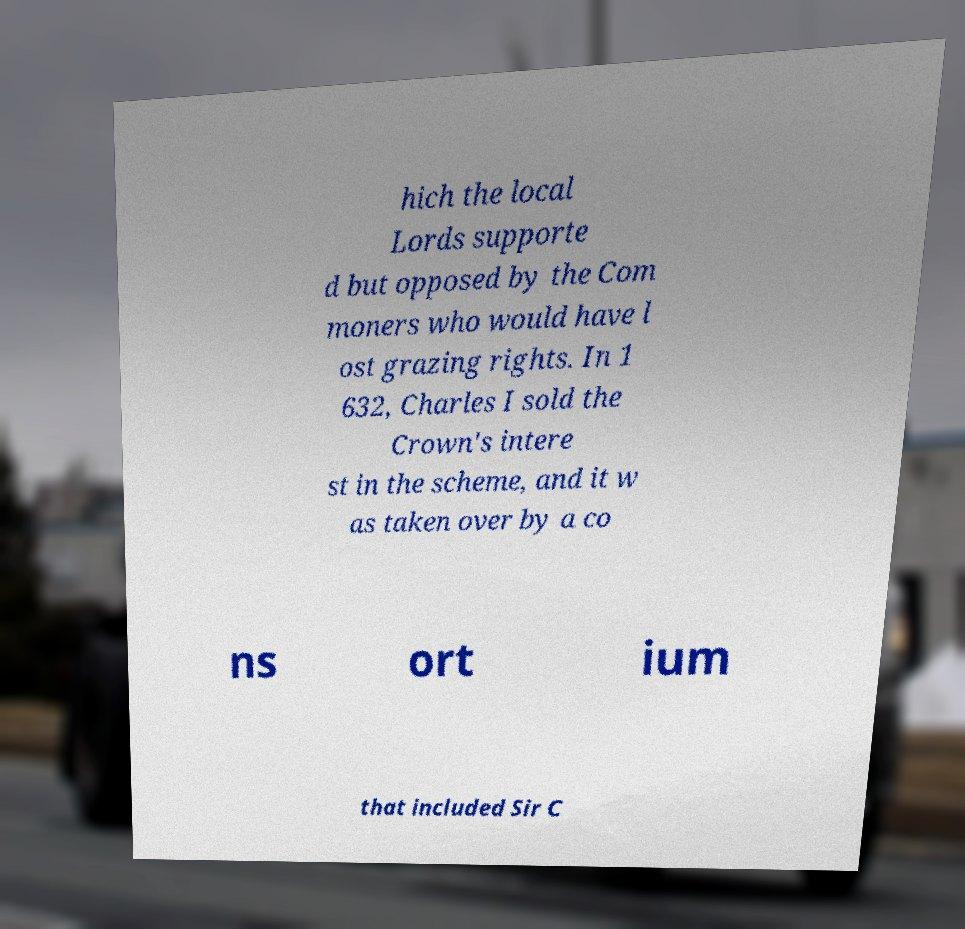What messages or text are displayed in this image? I need them in a readable, typed format. hich the local Lords supporte d but opposed by the Com moners who would have l ost grazing rights. In 1 632, Charles I sold the Crown's intere st in the scheme, and it w as taken over by a co ns ort ium that included Sir C 